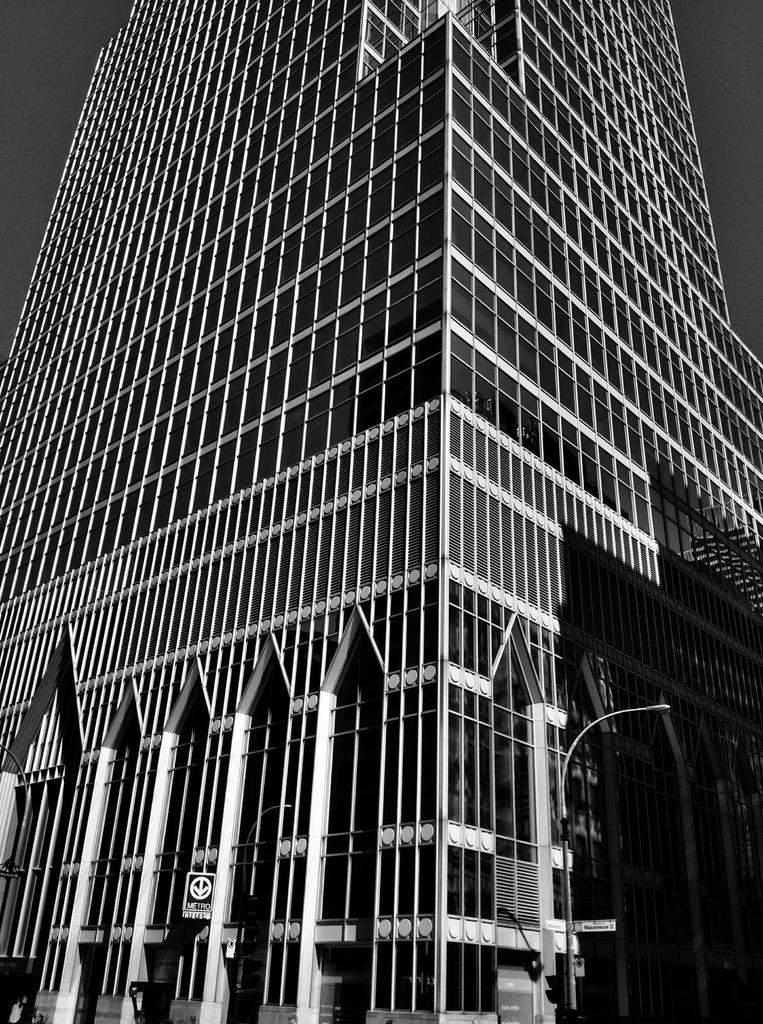What is the color scheme of the image? The image is black and white. What type of structure can be seen in the image? There is a building in the image. What part of the natural environment is visible in the image? The sky is visible in the image. How many toes can be seen on the building in the image? There are no toes present in the image, as it features a building and toes are a part of the human body. What type of stove is visible in the image? There is no stove present in the image. 